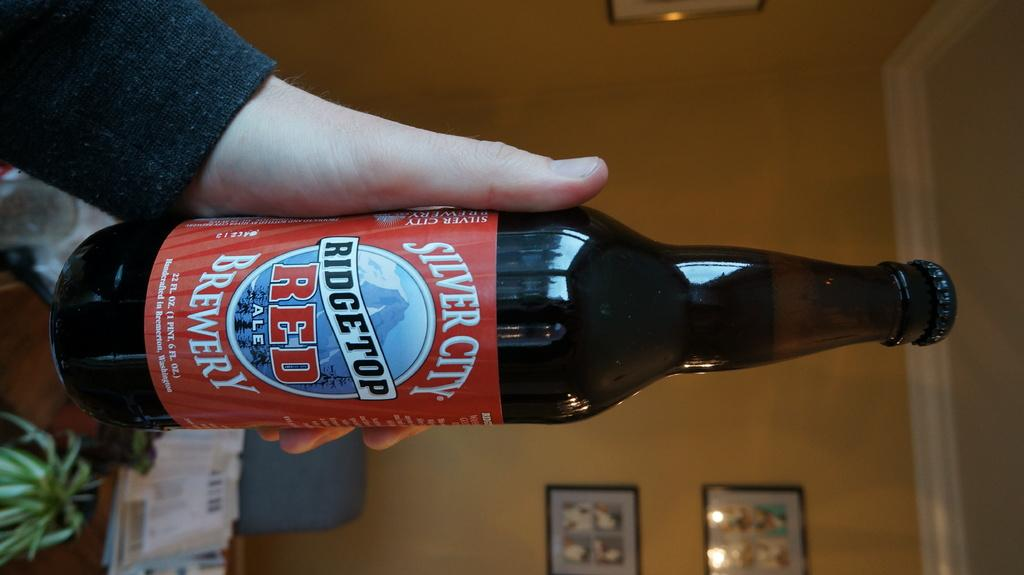What is the person's hand holding in the image? There is a person's hand holding a bottle in the image. What can be seen in the background of the image? There is a plant and papers in the background of the image. What is located near the wall in the background of the image? There is an object near the wall in the background of the image. What is hanging on the wall in the background of the image? There are photo frames on the wall in the background of the image. What type of sand can be seen in the image? There is no sand present in the image. What error can be seen in the photo frames on the wall? There is no error visible in the photo frames on the wall; they appear to be correctly displayed. 